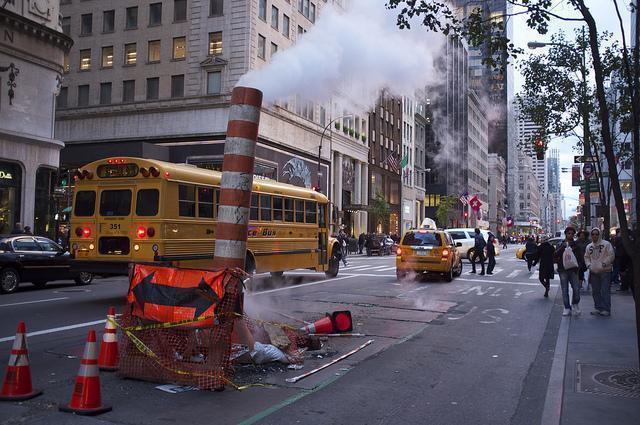What is the long vehicle for?
Pick the right solution, then justify: 'Answer: answer
Rationale: rationale.'
Options: Transporting children, transporting cars, transporting horses, transporting goods. Answer: transporting children.
Rationale: The long vehicle is a school bus, and it says so on the side. schools are usually reserved for young people. 